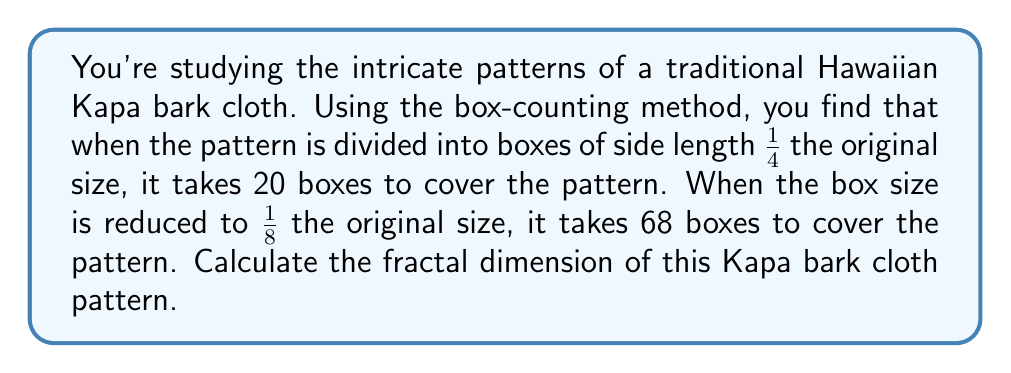Could you help me with this problem? To calculate the fractal dimension using the box-counting method, we'll use the formula:

$$ D = \frac{\log(N_2) - \log(N_1)}{\log(1/r_2) - \log(1/r_1)} $$

Where:
$D$ is the fractal dimension
$N_1$ and $N_2$ are the number of boxes at different scales
$r_1$ and $r_2$ are the corresponding scale factors

Step 1: Identify the known values
$N_1 = 20$ (boxes for 1/4 scale)
$N_2 = 68$ (boxes for 1/8 scale)
$r_1 = 1/4$
$r_2 = 1/8$

Step 2: Substitute these values into the formula

$$ D = \frac{\log(68) - \log(20)}{\log(8) - \log(4)} $$

Step 3: Simplify the numerator and denominator

$$ D = \frac{\log(68/20)}{\log(2)} $$

Step 4: Calculate the result

$$ D = \frac{\log(3.4)}{\log(2)} \approx 1.7655 $$

This fractal dimension between 1 and 2 indicates that the Kapa bark cloth pattern has a complexity between a line (dimension 1) and a filled plane (dimension 2), which is typical for intricate, self-similar patterns found in traditional art.
Answer: $1.7655$ 